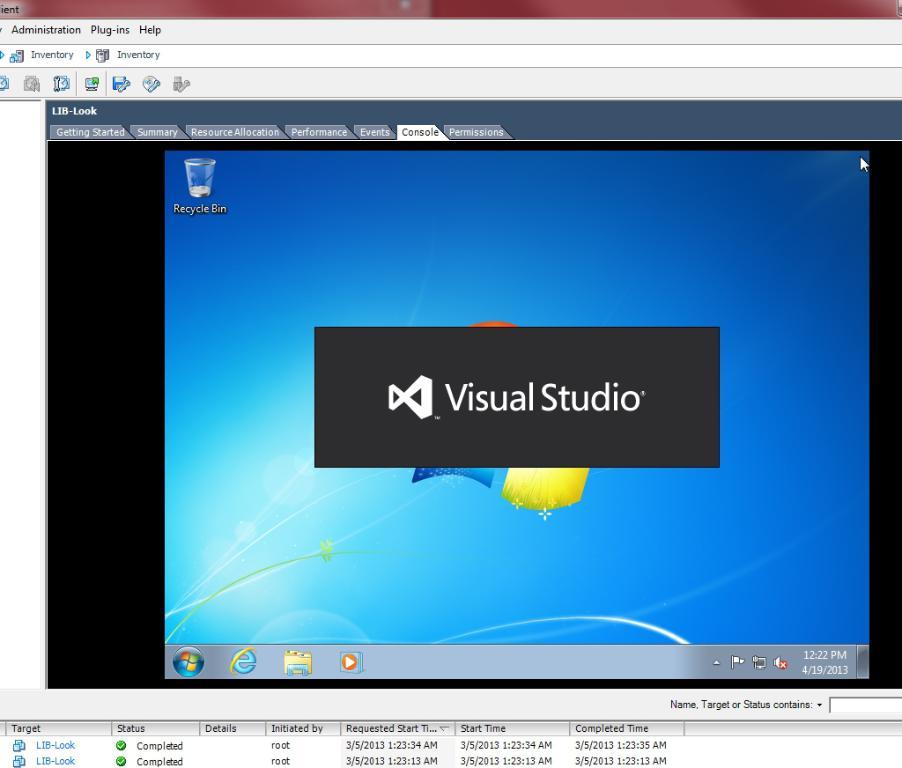<image>
Share a concise interpretation of the image provided. A Window's computer starting up Visual Studio program. 